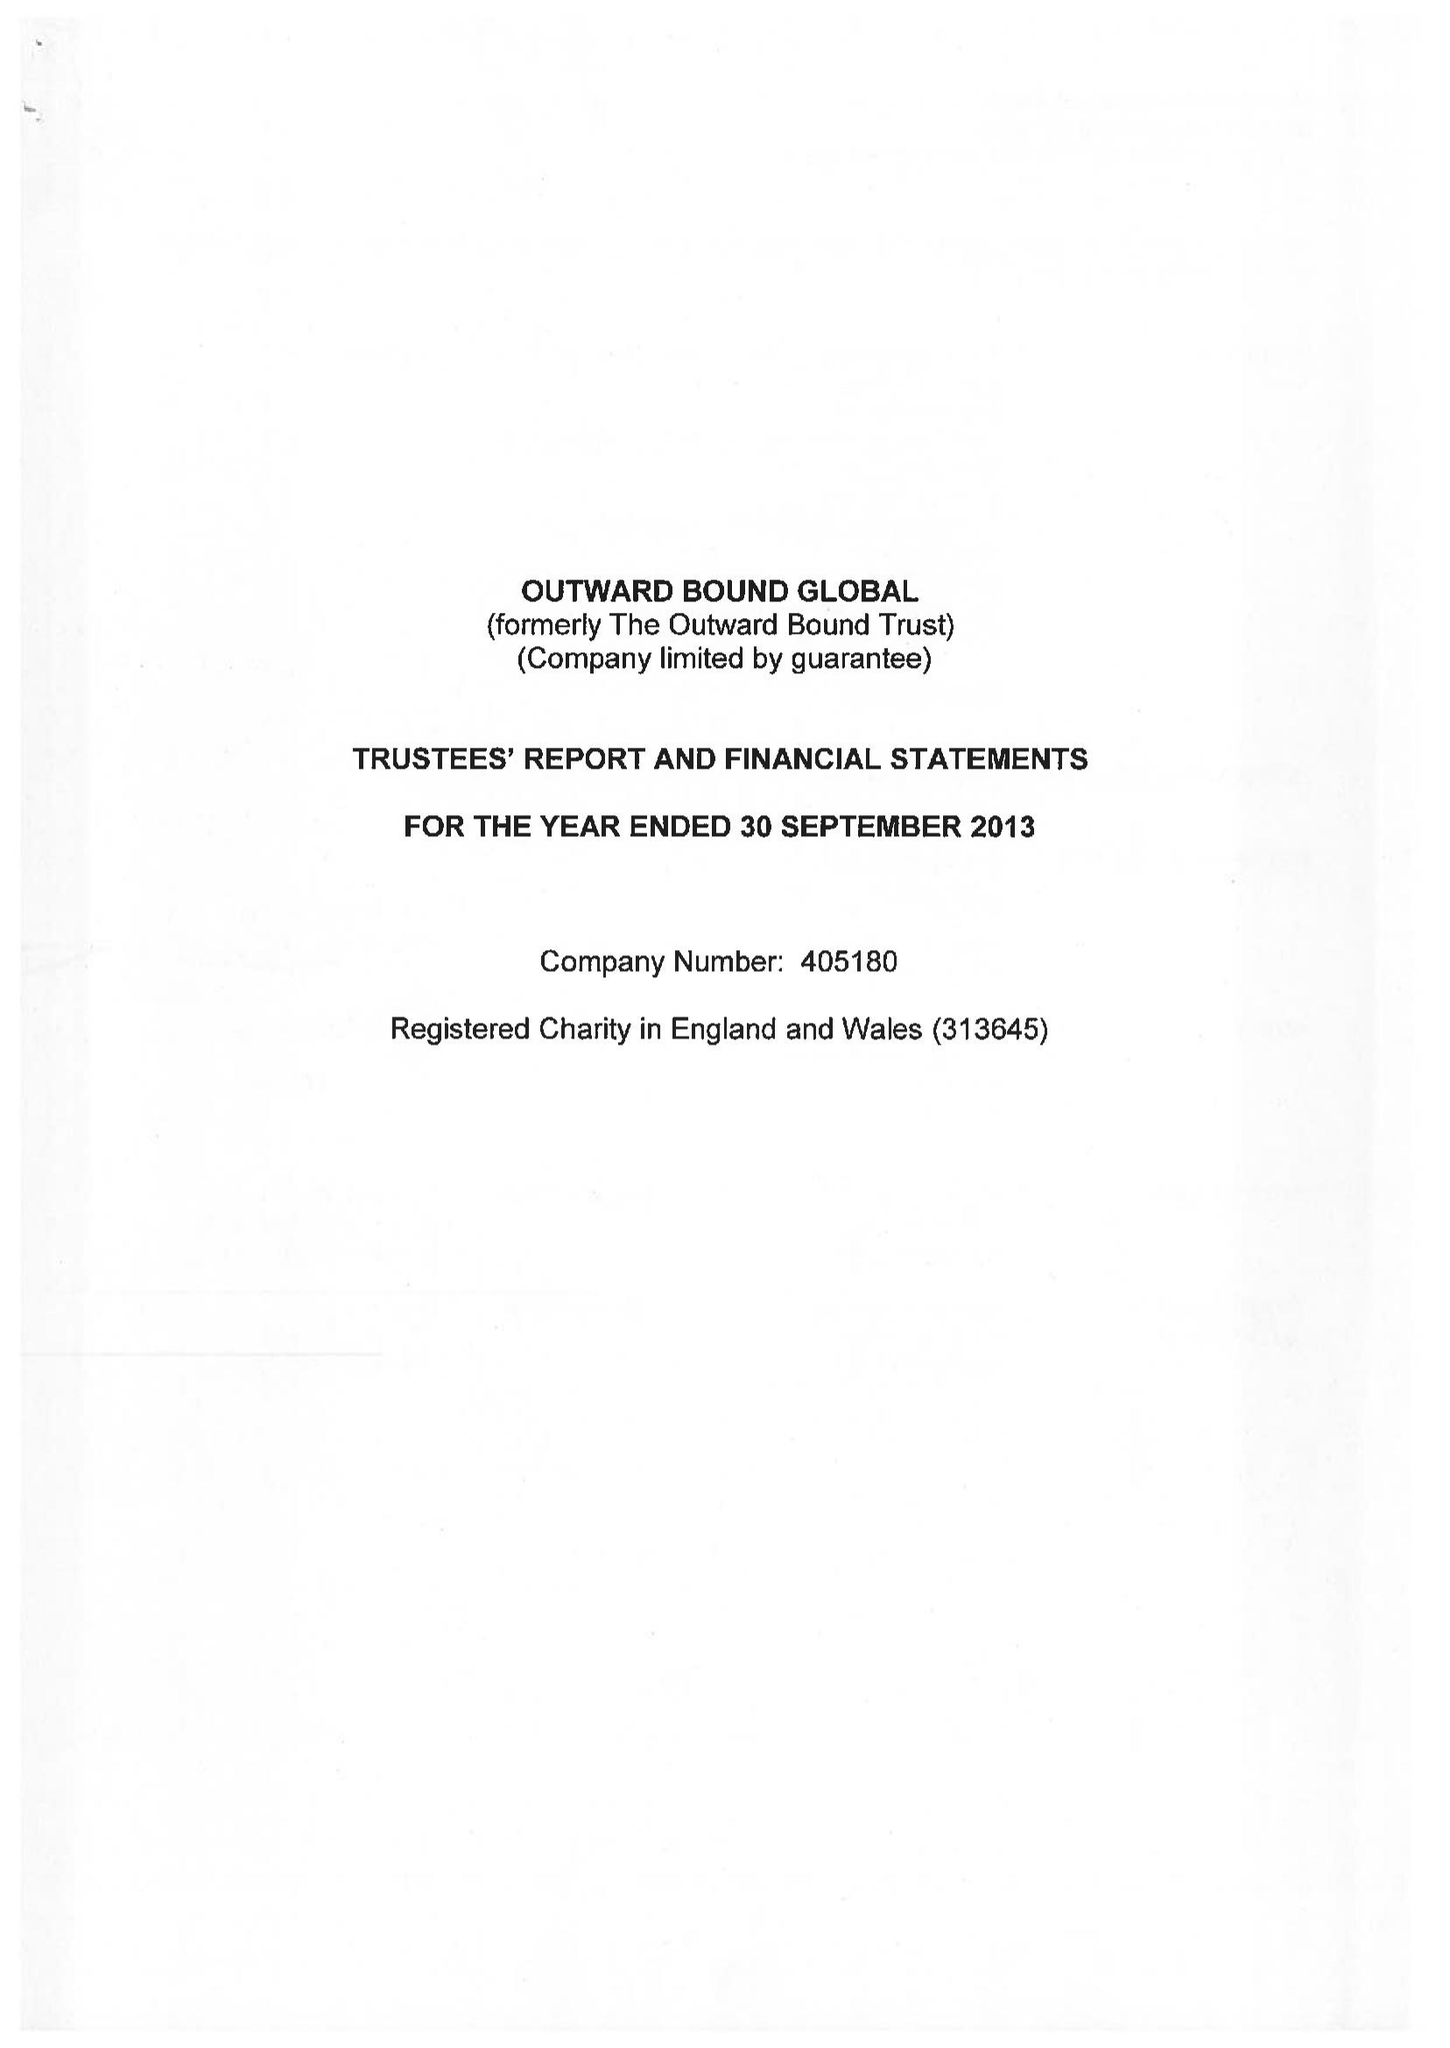What is the value for the charity_number?
Answer the question using a single word or phrase. 313645 